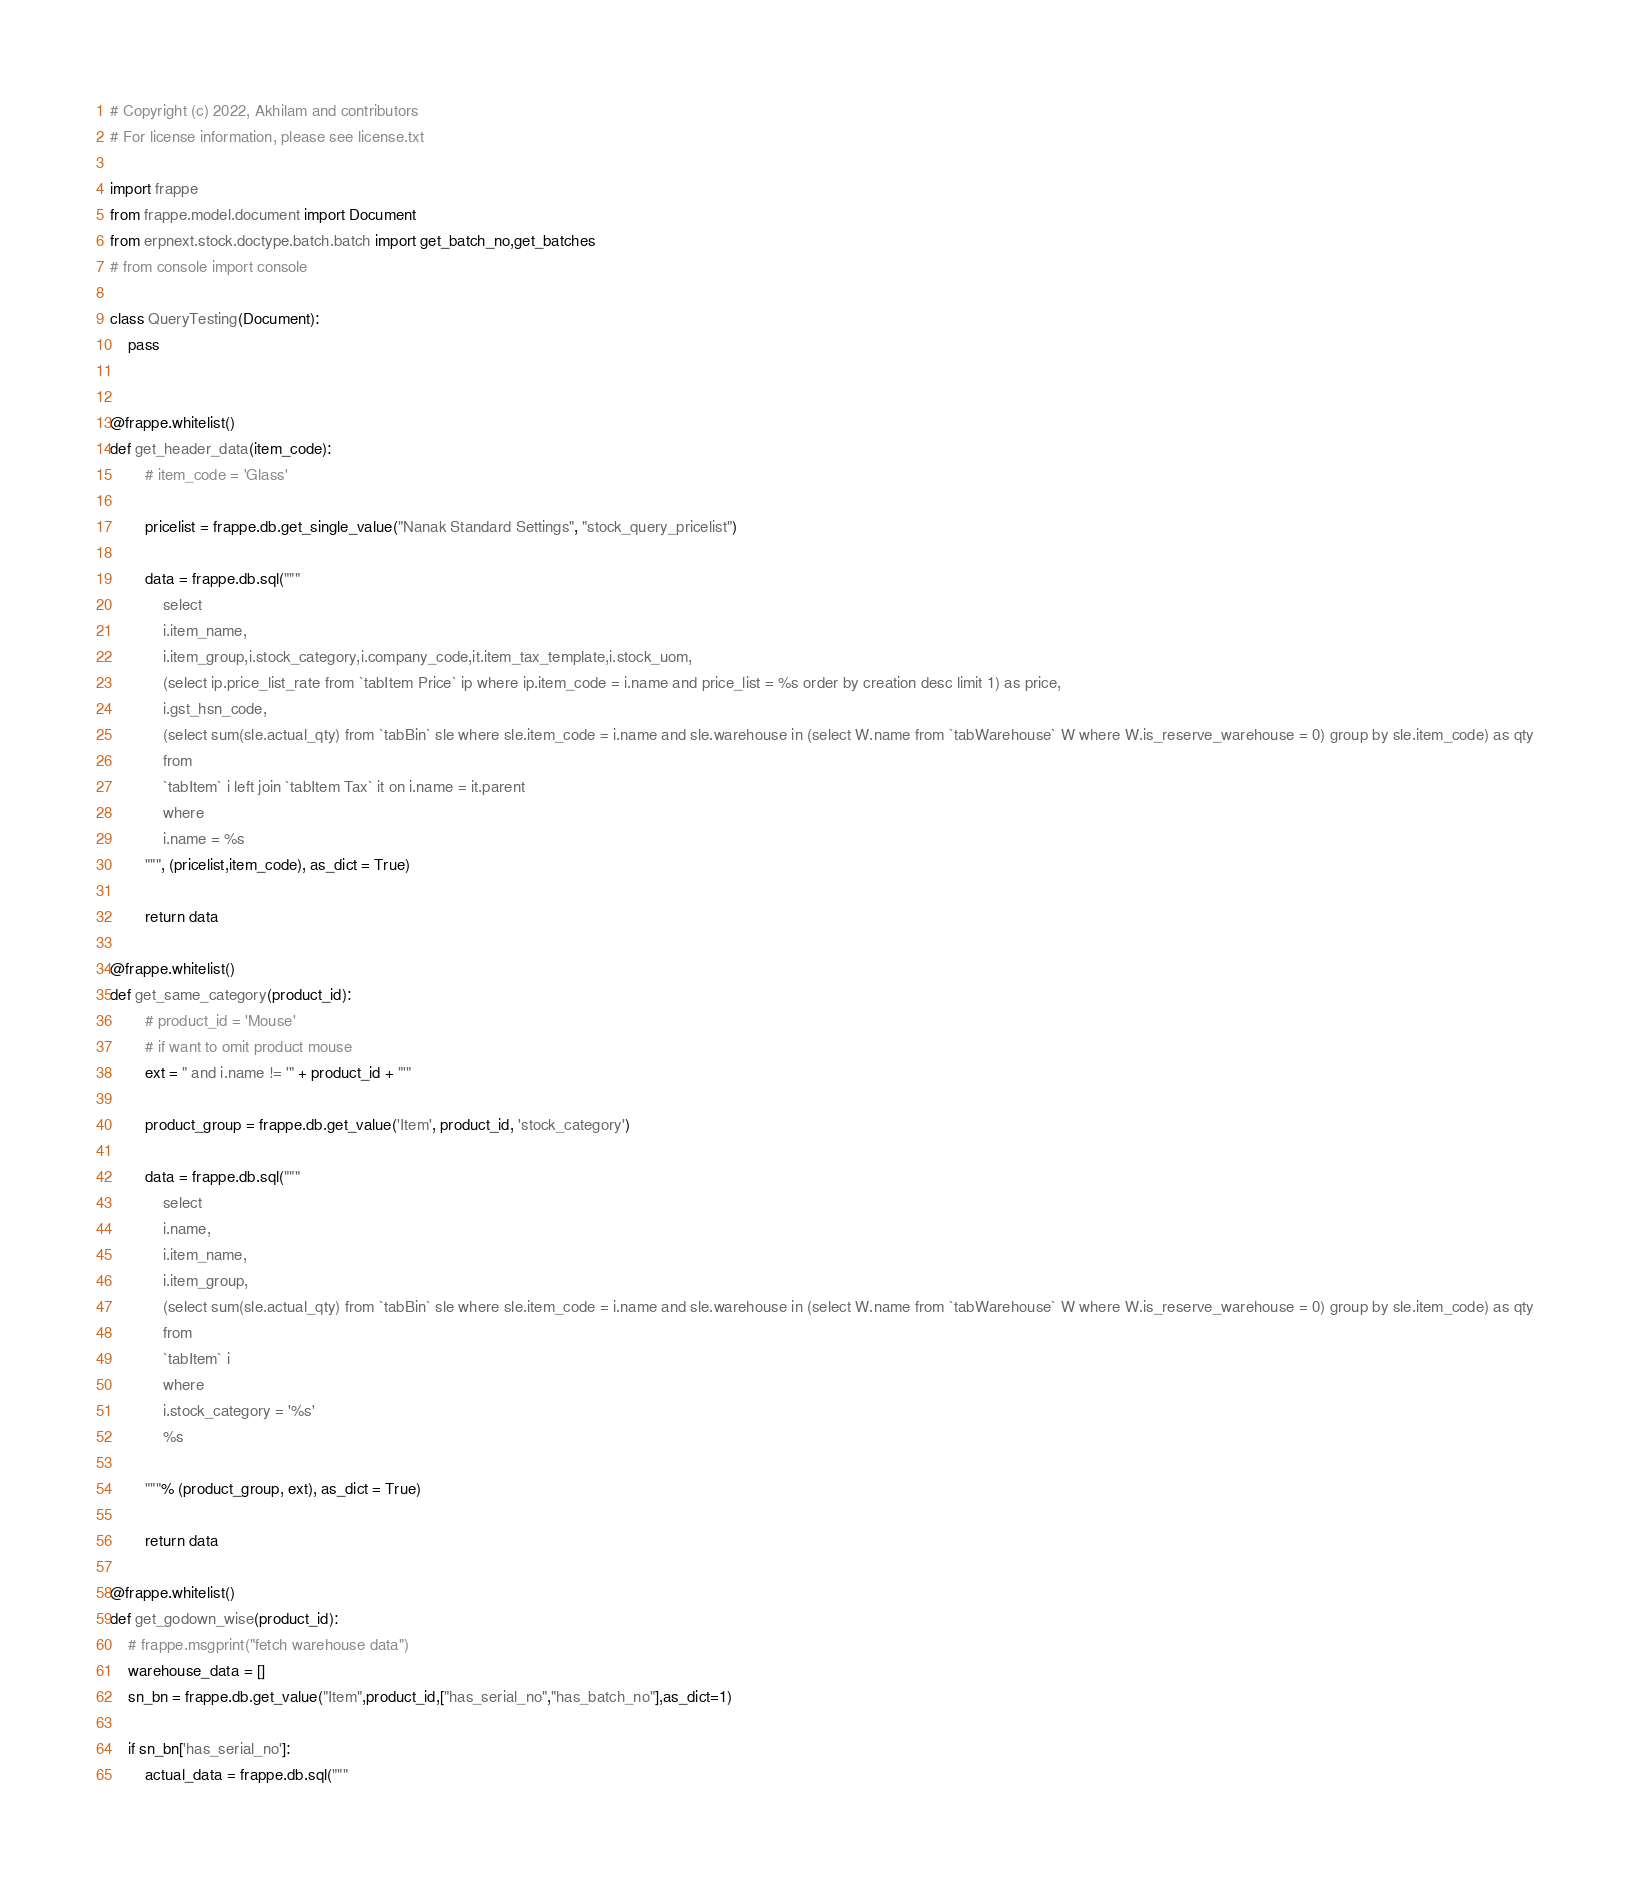<code> <loc_0><loc_0><loc_500><loc_500><_Python_># Copyright (c) 2022, Akhilam and contributors
# For license information, please see license.txt

import frappe
from frappe.model.document import Document
from erpnext.stock.doctype.batch.batch import get_batch_no,get_batches
# from console import console

class QueryTesting(Document):
	pass
	

@frappe.whitelist()
def get_header_data(item_code):
		# item_code = 'Glass'

		pricelist = frappe.db.get_single_value("Nanak Standard Settings", "stock_query_pricelist")

		data = frappe.db.sql("""
			select
			i.item_name,
			i.item_group,i.stock_category,i.company_code,it.item_tax_template,i.stock_uom,
			(select ip.price_list_rate from `tabItem Price` ip where ip.item_code = i.name and price_list = %s order by creation desc limit 1) as price,
			i.gst_hsn_code,
			(select sum(sle.actual_qty) from `tabBin` sle where sle.item_code = i.name and sle.warehouse in (select W.name from `tabWarehouse` W where W.is_reserve_warehouse = 0) group by sle.item_code) as qty
			from
			`tabItem` i left join `tabItem Tax` it on i.name = it.parent
			where
			i.name = %s
		""", (pricelist,item_code), as_dict = True)

		return data

@frappe.whitelist()
def get_same_category(product_id):
		# product_id = 'Mouse'
		# if want to omit product mouse
		ext = " and i.name != '" + product_id + "'"

		product_group = frappe.db.get_value('Item', product_id, 'stock_category')

		data = frappe.db.sql("""
			select
			i.name,
			i.item_name,
			i.item_group,
			(select sum(sle.actual_qty) from `tabBin` sle where sle.item_code = i.name and sle.warehouse in (select W.name from `tabWarehouse` W where W.is_reserve_warehouse = 0) group by sle.item_code) as qty
			from
			`tabItem` i
			where
			i.stock_category = '%s'
			%s
			
		"""% (product_group, ext), as_dict = True)

		return data

@frappe.whitelist()
def get_godown_wise(product_id):
	# frappe.msgprint("fetch warehouse data")
	warehouse_data = []
	sn_bn = frappe.db.get_value("Item",product_id,["has_serial_no","has_batch_no"],as_dict=1)

	if sn_bn['has_serial_no']:
		actual_data = frappe.db.sql("""</code> 